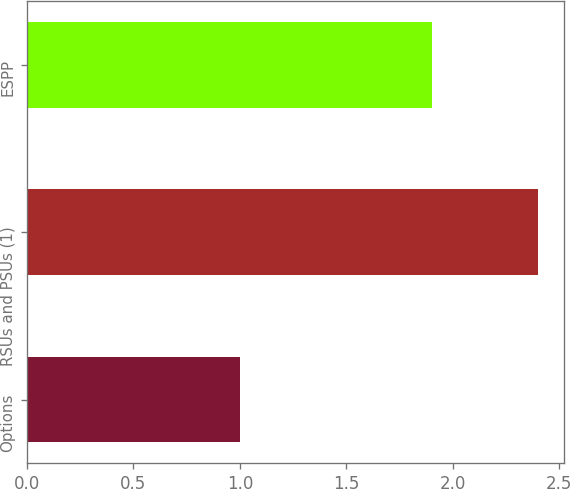<chart> <loc_0><loc_0><loc_500><loc_500><bar_chart><fcel>Options<fcel>RSUs and PSUs (1)<fcel>ESPP<nl><fcel>1<fcel>2.4<fcel>1.9<nl></chart> 